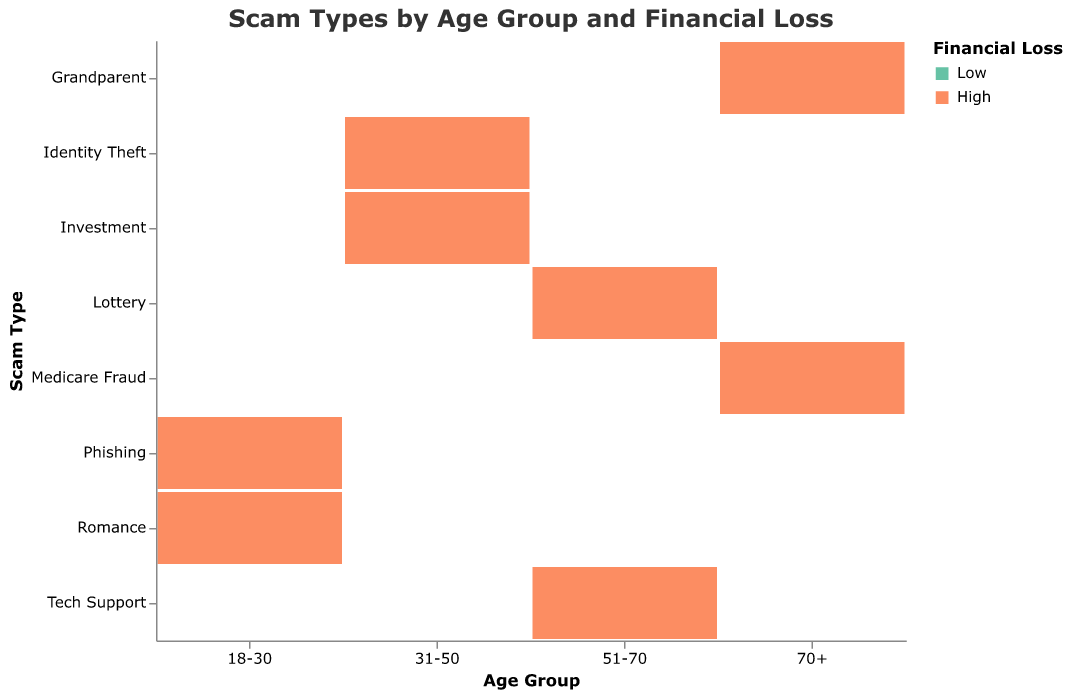What is the most commonly reported scam type for the age group 18-30? By examining the plot, focus on the rectangles under the age group 18-30. Identify the rectangles with the largest size (indicating the greatest count). For 18-30, "Phishing" has the largest rectangles.
Answer: Phishing Which age group has the highest number of reports for high financial losses due to Tech Support scams? Look for the age groups under the "Tech Support" scam type. Compare the sizes of the high financial loss rectangles (colored differently). The largest rectangle belongs to the age group 51-70.
Answer: 51-70 How many more reports of low financial loss are there compared to high financial loss for Romance scams in the 18-30 age group? Under the age group 18-30 and scam type "Romance", identify both the low and high financial loss rectangles. Extract their counts (low: 80, high: 30). Subtract the high count from the low count. 80 - 30 = 50
Answer: 50 Which scam type has the highest overall count of reports for the age group 70+? Examine the rectangles for each scam type under the age group 70+. Sum the counts of both high and low losses for each scam type. "Medicare Fraud" (low: 180, high: 95) has the highest overall count (275).
Answer: Medicare Fraud In the age group 31-50, which scam type has a higher number of high financial loss reports: Identity Theft or Investment? Look under the age group 31-50, comparing the sizes of high financial loss rectangles for "Identity Theft" and "Investment." "Investment" has a slightly larger rectangle.
Answer: Investment What is the total number of low financial loss reports for Tech Support and Lottery scams in the age group 51-70? Sum the counts of low financial loss reports for "Tech Support" (200) and "Lottery" (130) in the age group 51-70. 200 + 130 = 330
Answer: 330 Which age group has the smallest number of reported high financial losses in Romance scams? Identify the age group rectangles under "Romance" with the high financial loss color. Since "Romance" only appears in 18-30, compare the counts within 18-30, which is 30.
Answer: 18-30 How does the number of high financial loss reports in Medicare Fraud compare to Grandparent scams for the 70+ age group? Under the age group 70+, compare the high financial loss rectangles' sizes for "Medicare Fraud" and "Grandparent." "Medicare Fraud" has 95 high loss reports while "Grandparent" has 75.
Answer: Medicare Fraud is higher by 20 